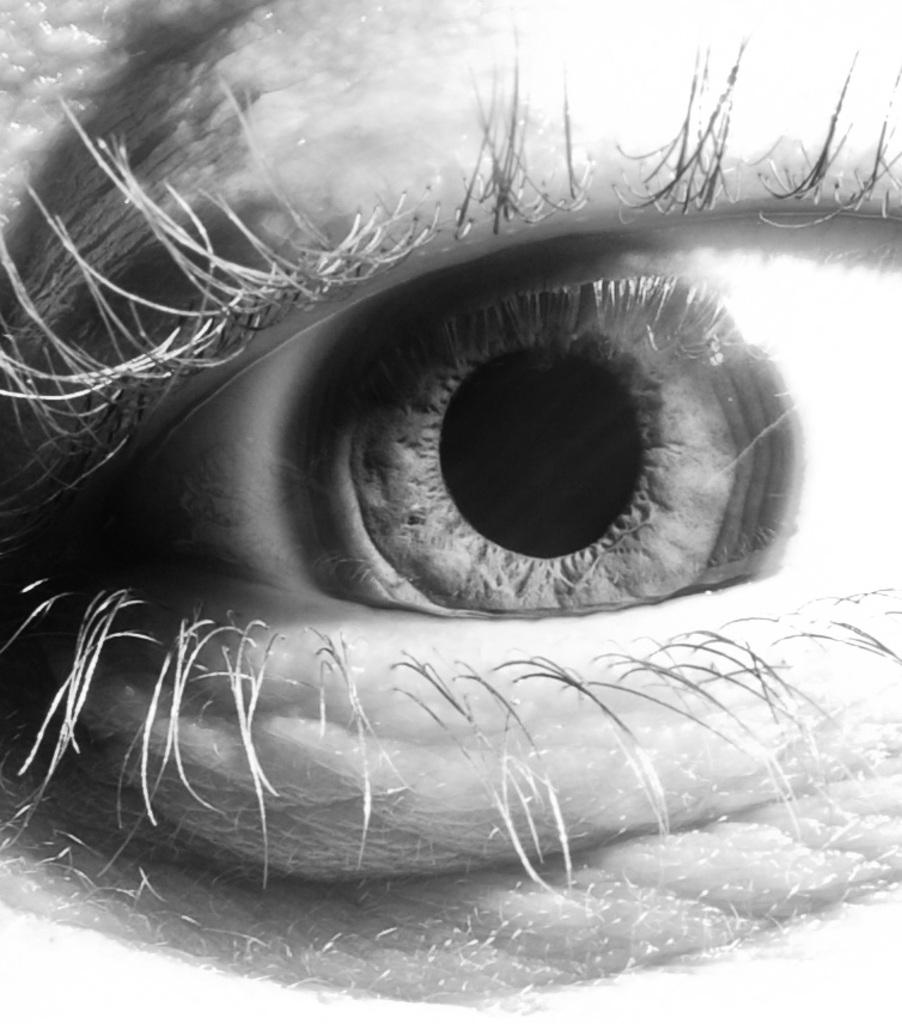What is the main subject of the image? The main subject of the image is an eye. Can you describe the details of the eye in the image? Unfortunately, the image is a zoomed-in view of the eye, so it is difficult to see the entire eye and its features. What type of wave can be seen crashing on the shore in the image? There is no wave present in the image; it is a zoomed-in view of an eye. Where is the scarecrow located in the image? There is no scarecrow present in the image; it is a zoomed-in view of an eye. 